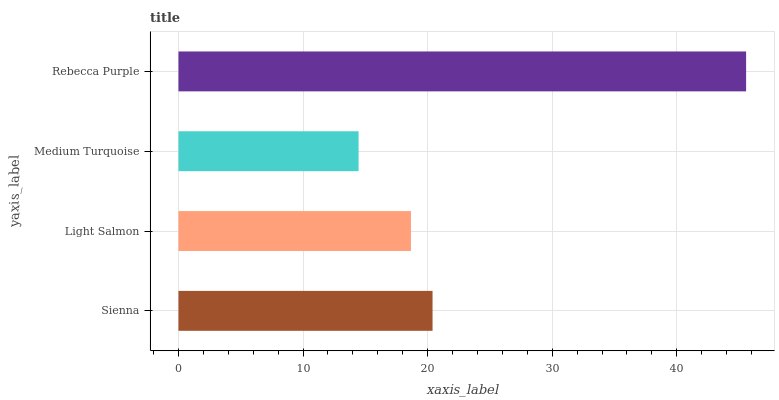Is Medium Turquoise the minimum?
Answer yes or no. Yes. Is Rebecca Purple the maximum?
Answer yes or no. Yes. Is Light Salmon the minimum?
Answer yes or no. No. Is Light Salmon the maximum?
Answer yes or no. No. Is Sienna greater than Light Salmon?
Answer yes or no. Yes. Is Light Salmon less than Sienna?
Answer yes or no. Yes. Is Light Salmon greater than Sienna?
Answer yes or no. No. Is Sienna less than Light Salmon?
Answer yes or no. No. Is Sienna the high median?
Answer yes or no. Yes. Is Light Salmon the low median?
Answer yes or no. Yes. Is Rebecca Purple the high median?
Answer yes or no. No. Is Rebecca Purple the low median?
Answer yes or no. No. 